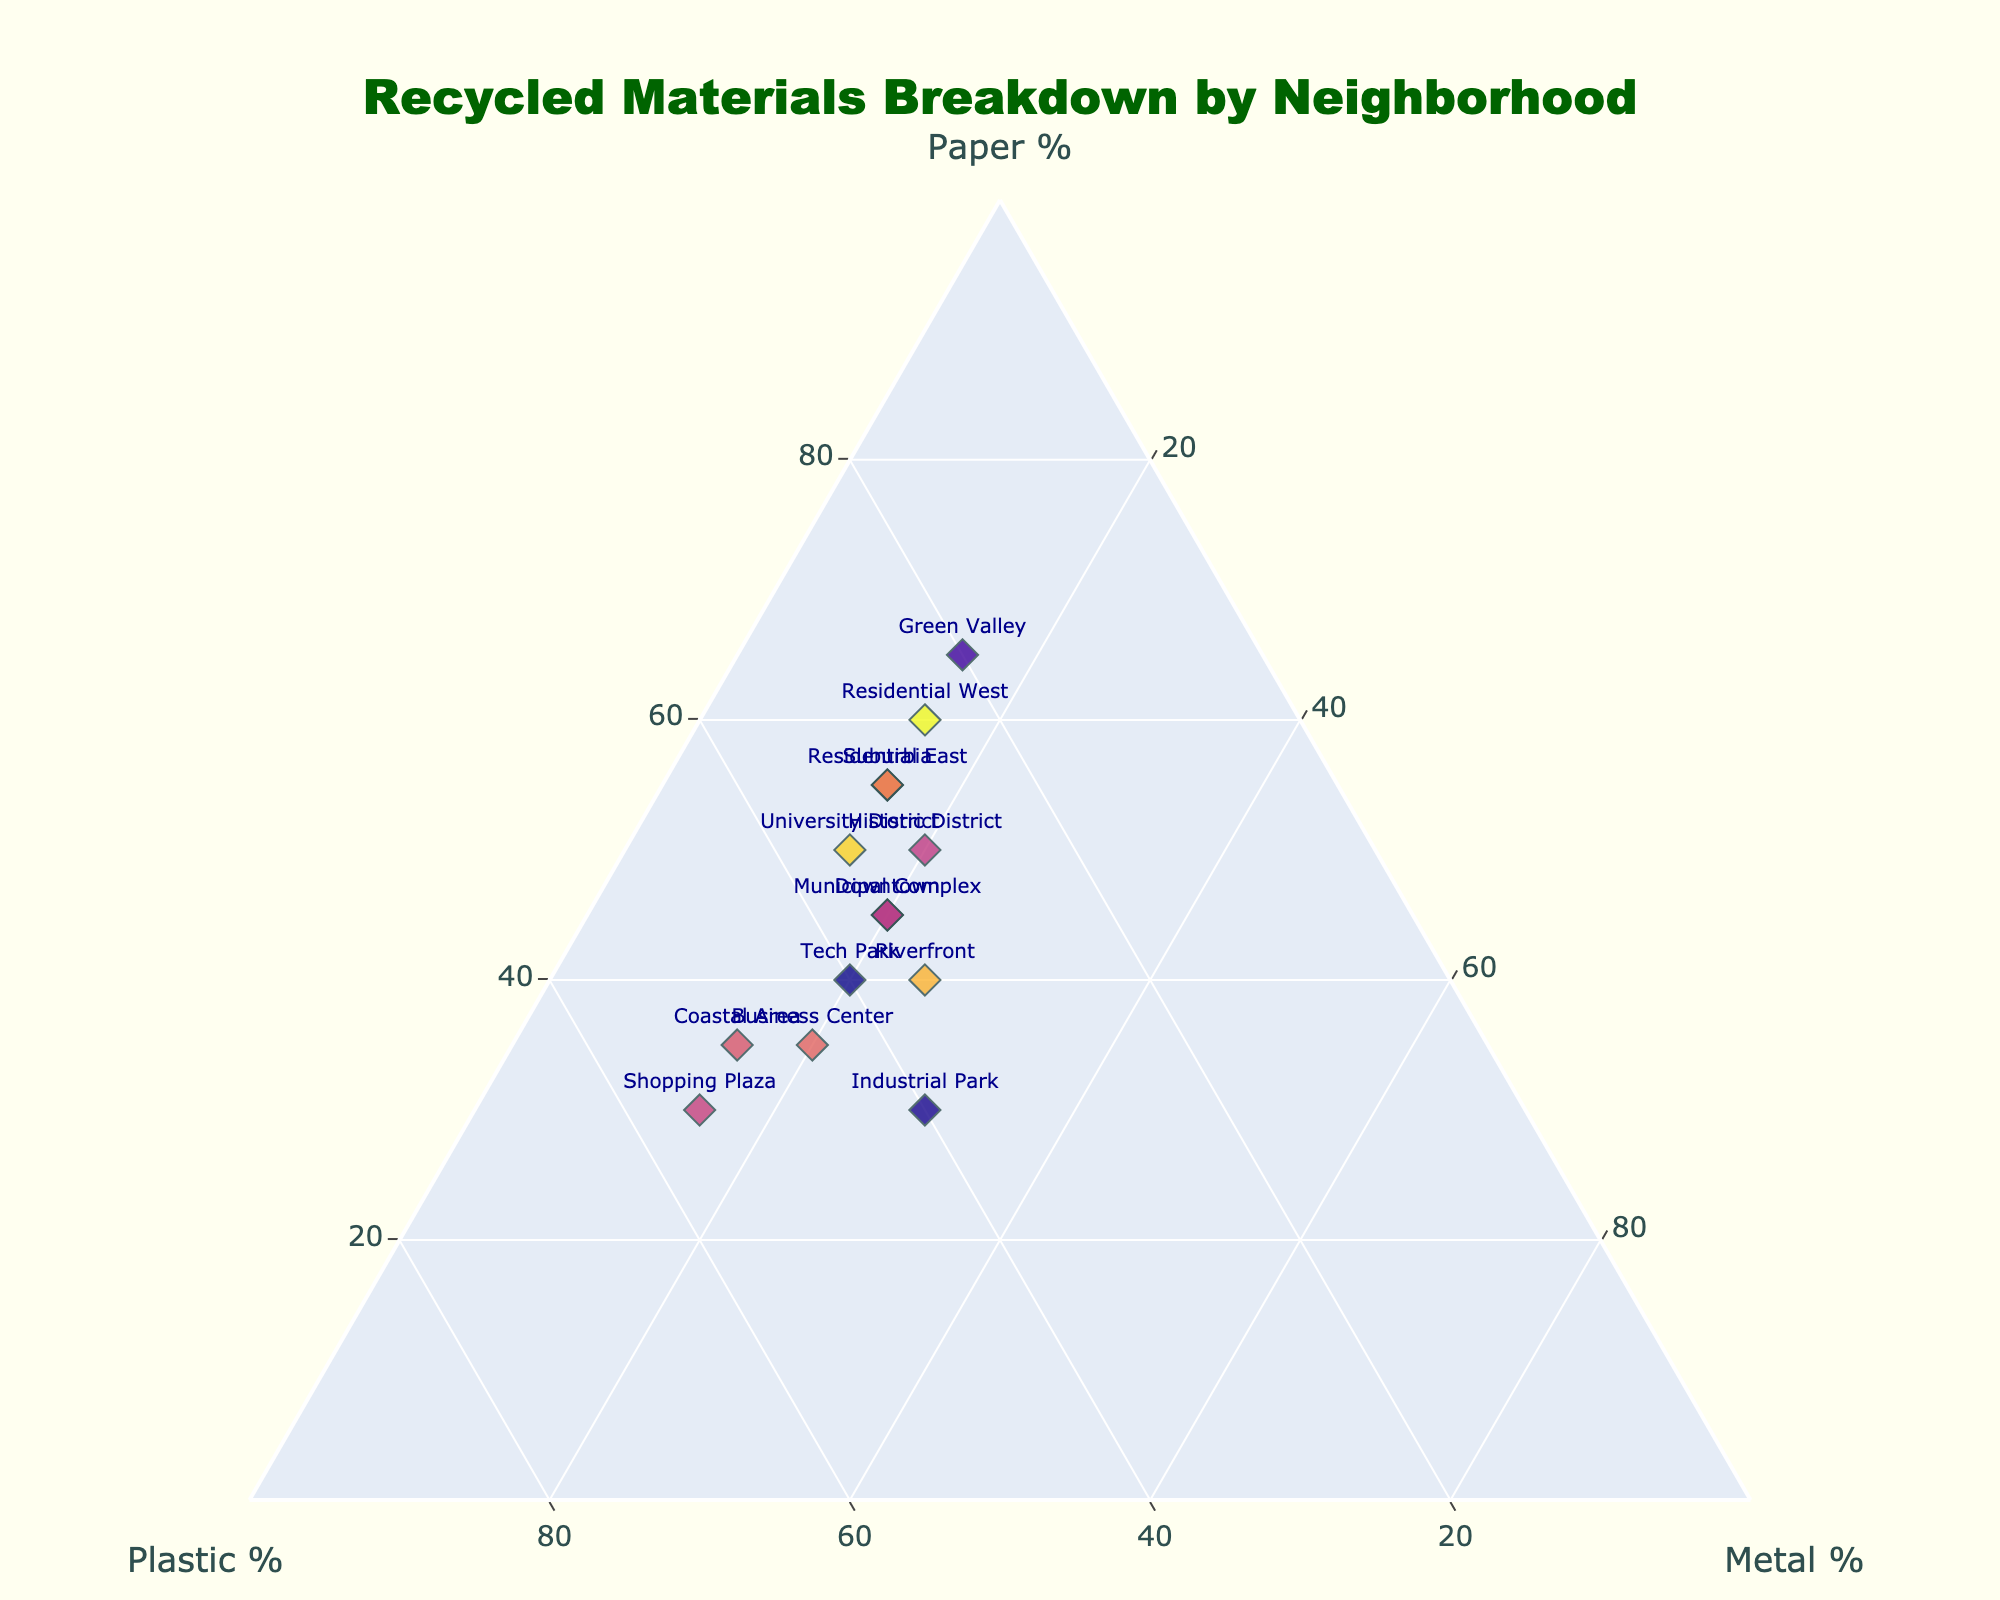What is the title of the plot? The title can be seen at the top of the plot. It reads: "Recycled Materials Breakdown by Neighborhood."
Answer: Recycled Materials Breakdown by Neighborhood How many neighborhoods have less than 20% of their recycled materials as metal? By looking at the metal axis, we identify the neighborhoods with metal percentages below the 20% mark. These neighborhoods are Suburbia, University District, Residential West, Residential East, Coastal Area, Historic District, Shopping Plaza, and Green Valley.
Answer: 8 Which neighborhood has the highest percentage of plastic? We look at the plastic axis to find the highest percentage, which corresponds to Shopping Plaza at 55%.
Answer: Shopping Plaza What do the marker colors represent? The marker colors are randomly assigned to differentiate between neighborhoods, and they do not encode any specific data information.
Answer: Random differentiation Which neighborhood has an equal percentage of plastic and metal recycling? Only Industrial Park and Tech Park exhibit equal percentages of plastic and metal, both at 40% and 20%, respectively.
Answer: Industrial Park, Tech Park How many neighborhoods have more than 50% paper recycling? Check the paper axis. The neighborhoods surpassing the 50% mark are Suburbia, Residential West, Residential East, Historic District, and Green Valley.
Answer: 5 Between Riverfront and Tech Park, which neighborhood has a higher percentage of metal recycling? We compare the metal recycling percentages of Riverfront (25%) and Tech Park (20%).
Answer: Riverfront What is the sum percentage of plastic and metal recycling in Business Center? Business Center has 45% plastic and 20% metal. Summing these percentages: 45% + 20% = 65%.
Answer: 65% Which neighborhood has the lowest percentage of paper recycling while having more than 30% plastic recycling? After checking, we find that Shopping Plaza has the lowest paper recycling percentage (30%) and more than 30% plastic recycling (55%).
Answer: Shopping Plaza 